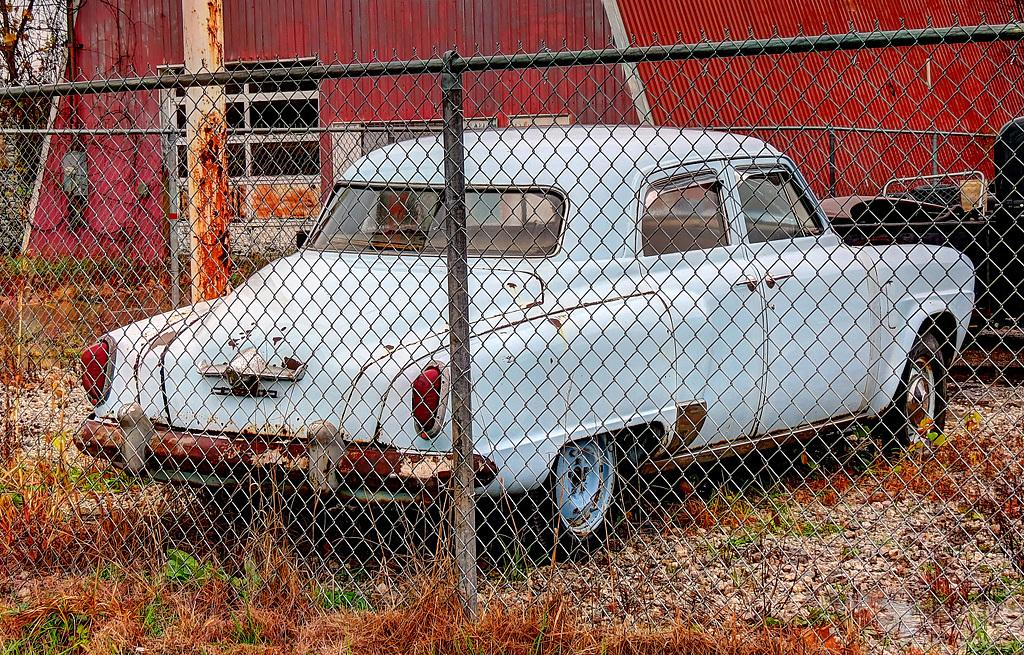What types of objects are on the ground in the image? There are vehicles on the ground in the image. What kind of structure can be seen in the image? There is a shed in the image. What type of vegetation is present in the image? There are trees in the image. Can you describe a specific feature in the image? There is a mesh in the image. What type of zinc is used to make the vehicles in the image? There is no mention of zinc being used in the vehicles in the image. How many socks can be seen hanging on the trees in the image? There are no socks present in the image; it features vehicles, a shed, trees, and a mesh. 